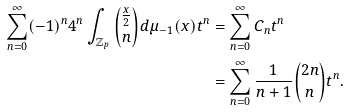<formula> <loc_0><loc_0><loc_500><loc_500>\sum _ { n = 0 } ^ { \infty } ( - 1 ) ^ { n } 4 ^ { n } \int _ { \mathbb { Z } _ { p } } { \frac { x } { 2 } \choose n } d \mu _ { - 1 } ( x ) t ^ { n } & = \sum _ { n = 0 } ^ { \infty } C _ { n } t ^ { n } \\ & = \sum _ { n = 0 } ^ { \infty } \frac { 1 } { n + 1 } { 2 n \choose n } t ^ { n } .</formula> 